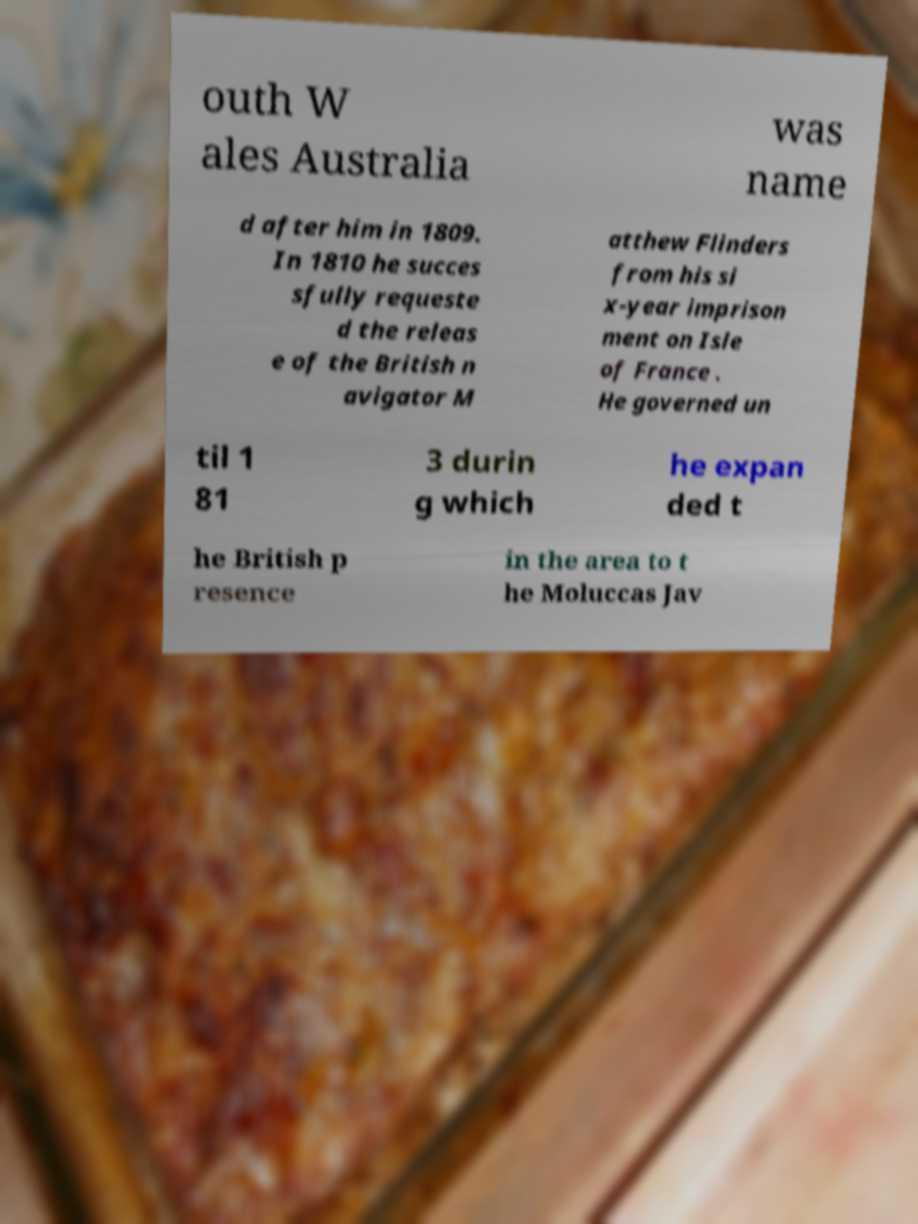I need the written content from this picture converted into text. Can you do that? outh W ales Australia was name d after him in 1809. In 1810 he succes sfully requeste d the releas e of the British n avigator M atthew Flinders from his si x-year imprison ment on Isle of France . He governed un til 1 81 3 durin g which he expan ded t he British p resence in the area to t he Moluccas Jav 